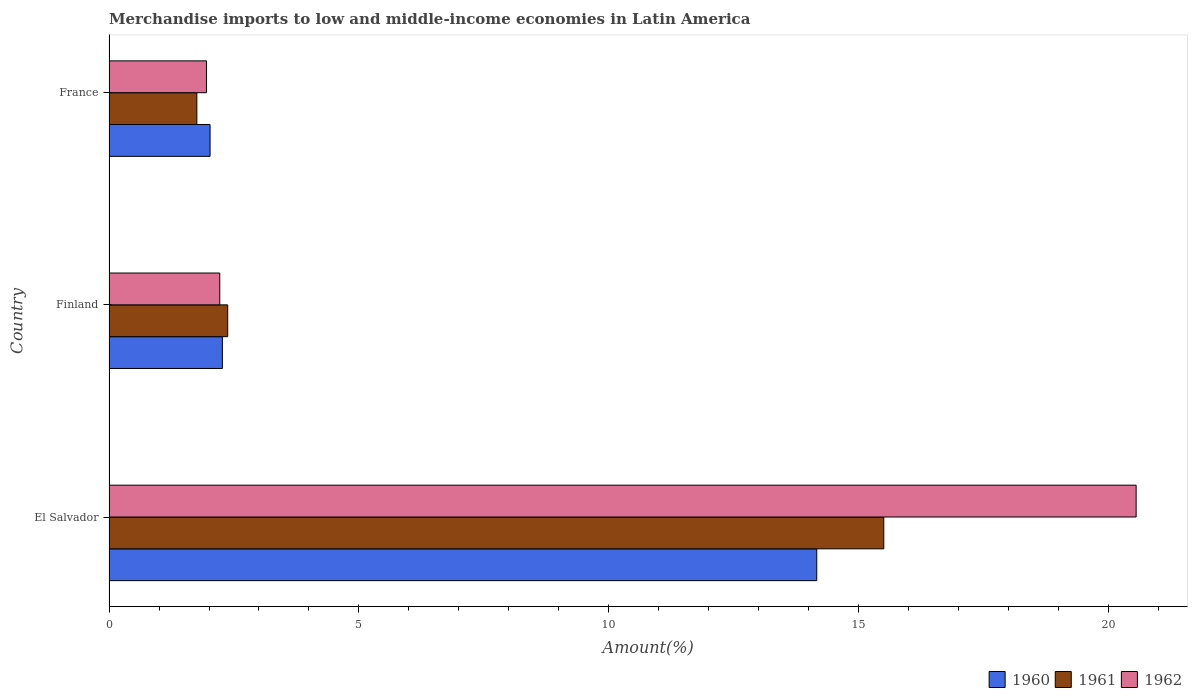How many different coloured bars are there?
Give a very brief answer. 3. How many groups of bars are there?
Keep it short and to the point. 3. Are the number of bars per tick equal to the number of legend labels?
Offer a terse response. Yes. Are the number of bars on each tick of the Y-axis equal?
Your response must be concise. Yes. What is the percentage of amount earned from merchandise imports in 1961 in El Salvador?
Your answer should be very brief. 15.5. Across all countries, what is the maximum percentage of amount earned from merchandise imports in 1961?
Offer a terse response. 15.5. Across all countries, what is the minimum percentage of amount earned from merchandise imports in 1962?
Make the answer very short. 1.95. In which country was the percentage of amount earned from merchandise imports in 1962 maximum?
Make the answer very short. El Salvador. What is the total percentage of amount earned from merchandise imports in 1961 in the graph?
Offer a terse response. 19.63. What is the difference between the percentage of amount earned from merchandise imports in 1962 in El Salvador and that in France?
Provide a short and direct response. 18.6. What is the difference between the percentage of amount earned from merchandise imports in 1960 in El Salvador and the percentage of amount earned from merchandise imports in 1962 in Finland?
Your response must be concise. 11.94. What is the average percentage of amount earned from merchandise imports in 1961 per country?
Your answer should be compact. 6.54. What is the difference between the percentage of amount earned from merchandise imports in 1961 and percentage of amount earned from merchandise imports in 1962 in Finland?
Ensure brevity in your answer.  0.16. In how many countries, is the percentage of amount earned from merchandise imports in 1962 greater than 6 %?
Provide a succinct answer. 1. What is the ratio of the percentage of amount earned from merchandise imports in 1960 in El Salvador to that in Finland?
Provide a short and direct response. 6.24. Is the percentage of amount earned from merchandise imports in 1961 in Finland less than that in France?
Ensure brevity in your answer.  No. What is the difference between the highest and the second highest percentage of amount earned from merchandise imports in 1961?
Keep it short and to the point. 13.12. What is the difference between the highest and the lowest percentage of amount earned from merchandise imports in 1961?
Your response must be concise. 13.74. In how many countries, is the percentage of amount earned from merchandise imports in 1962 greater than the average percentage of amount earned from merchandise imports in 1962 taken over all countries?
Your answer should be compact. 1. What does the 1st bar from the top in El Salvador represents?
Your response must be concise. 1962. How many countries are there in the graph?
Provide a succinct answer. 3. Are the values on the major ticks of X-axis written in scientific E-notation?
Ensure brevity in your answer.  No. Does the graph contain any zero values?
Provide a succinct answer. No. Where does the legend appear in the graph?
Offer a very short reply. Bottom right. How are the legend labels stacked?
Your answer should be compact. Horizontal. What is the title of the graph?
Your answer should be compact. Merchandise imports to low and middle-income economies in Latin America. Does "1981" appear as one of the legend labels in the graph?
Your answer should be very brief. No. What is the label or title of the X-axis?
Provide a succinct answer. Amount(%). What is the label or title of the Y-axis?
Keep it short and to the point. Country. What is the Amount(%) in 1960 in El Salvador?
Give a very brief answer. 14.16. What is the Amount(%) of 1961 in El Salvador?
Make the answer very short. 15.5. What is the Amount(%) of 1962 in El Salvador?
Provide a succinct answer. 20.55. What is the Amount(%) in 1960 in Finland?
Your answer should be compact. 2.27. What is the Amount(%) in 1961 in Finland?
Your answer should be compact. 2.37. What is the Amount(%) of 1962 in Finland?
Your answer should be compact. 2.22. What is the Amount(%) in 1960 in France?
Your answer should be very brief. 2.02. What is the Amount(%) in 1961 in France?
Make the answer very short. 1.76. What is the Amount(%) of 1962 in France?
Your answer should be very brief. 1.95. Across all countries, what is the maximum Amount(%) of 1960?
Your answer should be compact. 14.16. Across all countries, what is the maximum Amount(%) of 1961?
Your response must be concise. 15.5. Across all countries, what is the maximum Amount(%) of 1962?
Keep it short and to the point. 20.55. Across all countries, what is the minimum Amount(%) in 1960?
Your answer should be compact. 2.02. Across all countries, what is the minimum Amount(%) in 1961?
Provide a succinct answer. 1.76. Across all countries, what is the minimum Amount(%) of 1962?
Keep it short and to the point. 1.95. What is the total Amount(%) of 1960 in the graph?
Provide a succinct answer. 18.45. What is the total Amount(%) of 1961 in the graph?
Your answer should be compact. 19.63. What is the total Amount(%) of 1962 in the graph?
Your answer should be compact. 24.71. What is the difference between the Amount(%) of 1960 in El Salvador and that in Finland?
Your answer should be very brief. 11.89. What is the difference between the Amount(%) of 1961 in El Salvador and that in Finland?
Make the answer very short. 13.12. What is the difference between the Amount(%) of 1962 in El Salvador and that in Finland?
Provide a succinct answer. 18.33. What is the difference between the Amount(%) in 1960 in El Salvador and that in France?
Your answer should be compact. 12.14. What is the difference between the Amount(%) in 1961 in El Salvador and that in France?
Offer a very short reply. 13.74. What is the difference between the Amount(%) in 1962 in El Salvador and that in France?
Make the answer very short. 18.6. What is the difference between the Amount(%) of 1960 in Finland and that in France?
Ensure brevity in your answer.  0.25. What is the difference between the Amount(%) of 1961 in Finland and that in France?
Your answer should be compact. 0.62. What is the difference between the Amount(%) in 1962 in Finland and that in France?
Provide a succinct answer. 0.27. What is the difference between the Amount(%) in 1960 in El Salvador and the Amount(%) in 1961 in Finland?
Your answer should be compact. 11.78. What is the difference between the Amount(%) in 1960 in El Salvador and the Amount(%) in 1962 in Finland?
Offer a very short reply. 11.94. What is the difference between the Amount(%) in 1961 in El Salvador and the Amount(%) in 1962 in Finland?
Offer a terse response. 13.28. What is the difference between the Amount(%) of 1960 in El Salvador and the Amount(%) of 1961 in France?
Make the answer very short. 12.4. What is the difference between the Amount(%) in 1960 in El Salvador and the Amount(%) in 1962 in France?
Your answer should be very brief. 12.21. What is the difference between the Amount(%) in 1961 in El Salvador and the Amount(%) in 1962 in France?
Your answer should be very brief. 13.55. What is the difference between the Amount(%) in 1960 in Finland and the Amount(%) in 1961 in France?
Provide a short and direct response. 0.51. What is the difference between the Amount(%) of 1960 in Finland and the Amount(%) of 1962 in France?
Make the answer very short. 0.32. What is the difference between the Amount(%) of 1961 in Finland and the Amount(%) of 1962 in France?
Give a very brief answer. 0.42. What is the average Amount(%) of 1960 per country?
Provide a succinct answer. 6.15. What is the average Amount(%) in 1961 per country?
Your answer should be very brief. 6.54. What is the average Amount(%) in 1962 per country?
Provide a succinct answer. 8.24. What is the difference between the Amount(%) in 1960 and Amount(%) in 1961 in El Salvador?
Make the answer very short. -1.34. What is the difference between the Amount(%) of 1960 and Amount(%) of 1962 in El Salvador?
Your response must be concise. -6.39. What is the difference between the Amount(%) of 1961 and Amount(%) of 1962 in El Salvador?
Your answer should be compact. -5.05. What is the difference between the Amount(%) in 1960 and Amount(%) in 1961 in Finland?
Provide a succinct answer. -0.11. What is the difference between the Amount(%) of 1960 and Amount(%) of 1962 in Finland?
Make the answer very short. 0.05. What is the difference between the Amount(%) of 1961 and Amount(%) of 1962 in Finland?
Make the answer very short. 0.16. What is the difference between the Amount(%) in 1960 and Amount(%) in 1961 in France?
Provide a short and direct response. 0.26. What is the difference between the Amount(%) of 1960 and Amount(%) of 1962 in France?
Give a very brief answer. 0.07. What is the difference between the Amount(%) in 1961 and Amount(%) in 1962 in France?
Your answer should be compact. -0.19. What is the ratio of the Amount(%) of 1960 in El Salvador to that in Finland?
Offer a terse response. 6.24. What is the ratio of the Amount(%) of 1961 in El Salvador to that in Finland?
Provide a short and direct response. 6.53. What is the ratio of the Amount(%) of 1962 in El Salvador to that in Finland?
Your answer should be very brief. 9.27. What is the ratio of the Amount(%) in 1960 in El Salvador to that in France?
Give a very brief answer. 7. What is the ratio of the Amount(%) of 1961 in El Salvador to that in France?
Provide a succinct answer. 8.82. What is the ratio of the Amount(%) of 1962 in El Salvador to that in France?
Keep it short and to the point. 10.54. What is the ratio of the Amount(%) of 1960 in Finland to that in France?
Your answer should be very brief. 1.12. What is the ratio of the Amount(%) in 1961 in Finland to that in France?
Keep it short and to the point. 1.35. What is the ratio of the Amount(%) in 1962 in Finland to that in France?
Give a very brief answer. 1.14. What is the difference between the highest and the second highest Amount(%) in 1960?
Provide a succinct answer. 11.89. What is the difference between the highest and the second highest Amount(%) in 1961?
Offer a terse response. 13.12. What is the difference between the highest and the second highest Amount(%) in 1962?
Offer a very short reply. 18.33. What is the difference between the highest and the lowest Amount(%) in 1960?
Your response must be concise. 12.14. What is the difference between the highest and the lowest Amount(%) in 1961?
Provide a short and direct response. 13.74. What is the difference between the highest and the lowest Amount(%) in 1962?
Your answer should be compact. 18.6. 